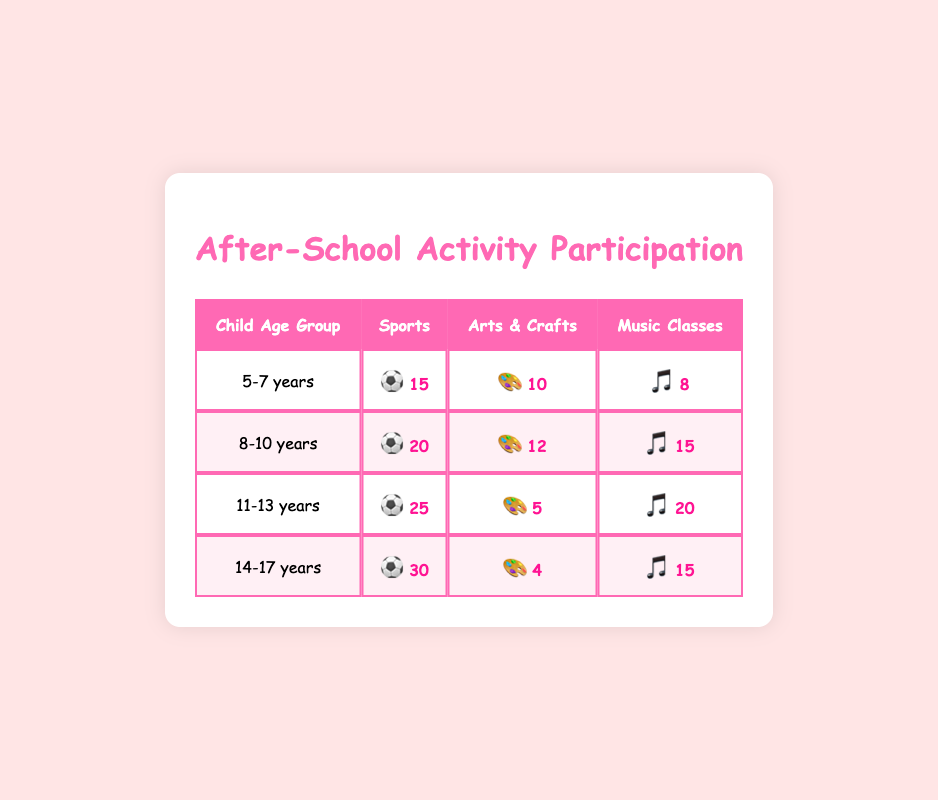What is the frequency of Sports participation for children aged 5-7 years? The frequency value for the "Sports" activity under the "5-7 years" age group is directly available in the table, which shows 15.
Answer: 15 What is the highest frequency of activity participation among children aged 14-17 years? By looking at the "14-17 years" row in the table, the activity with the highest frequency is "Sports," with a frequency of 30.
Answer: 30 How many children aged 11-13 years participate in Arts & Crafts? The table states that the frequency for the "Arts & Crafts" activity for the "11-13 years" age group is 5.
Answer: 5 Is the frequency of Music Classes for children aged 8-10 years greater than the frequency for Arts & Crafts for the same age group? The frequency for "Music Classes" in the "8-10 years" age group is 15, while for "Arts & Crafts," it is 12. Since 15 is greater than 12, the statement is true.
Answer: Yes What is the total frequency of Sports participation across all age groups? To find this, we sum up the frequencies of "Sports" from each age group: 15 (5-7 years) + 20 (8-10 years) + 25 (11-13 years) + 30 (14-17 years) = 90.
Answer: 90 Which activity has the lowest frequency for children aged 14-17 years? Looking at the "14-17 years" age group, "Arts & Crafts" has the lowest frequency at 4 compared to the other activities.
Answer: Arts & Crafts What is the average frequency of Arts & Crafts participation across all age groups? The frequencies for "Arts & Crafts" are 10 (5-7 years), 12 (8-10 years), 5 (11-13 years), and 4 (14-17 years). The average is calculated by summing them (10 + 12 + 5 + 4 = 31) and dividing by the number of data points (4): 31/4 = 7.75.
Answer: 7.75 Are more children aged 5-7 years participating in Music Classes or Arts & Crafts? The frequency for "Music Classes" in the "5-7 years" age group is 8, while for "Arts & Crafts," it is 10. Since 10 is greater than 8, the statement is false.
Answer: No What is the combined frequency of Music Classes for children aged 11-13 years and 14-17 years? We need to add the frequencies: for "Music Classes," it’s 20 (11-13 years) + 15 (14-17 years) = 35.
Answer: 35 